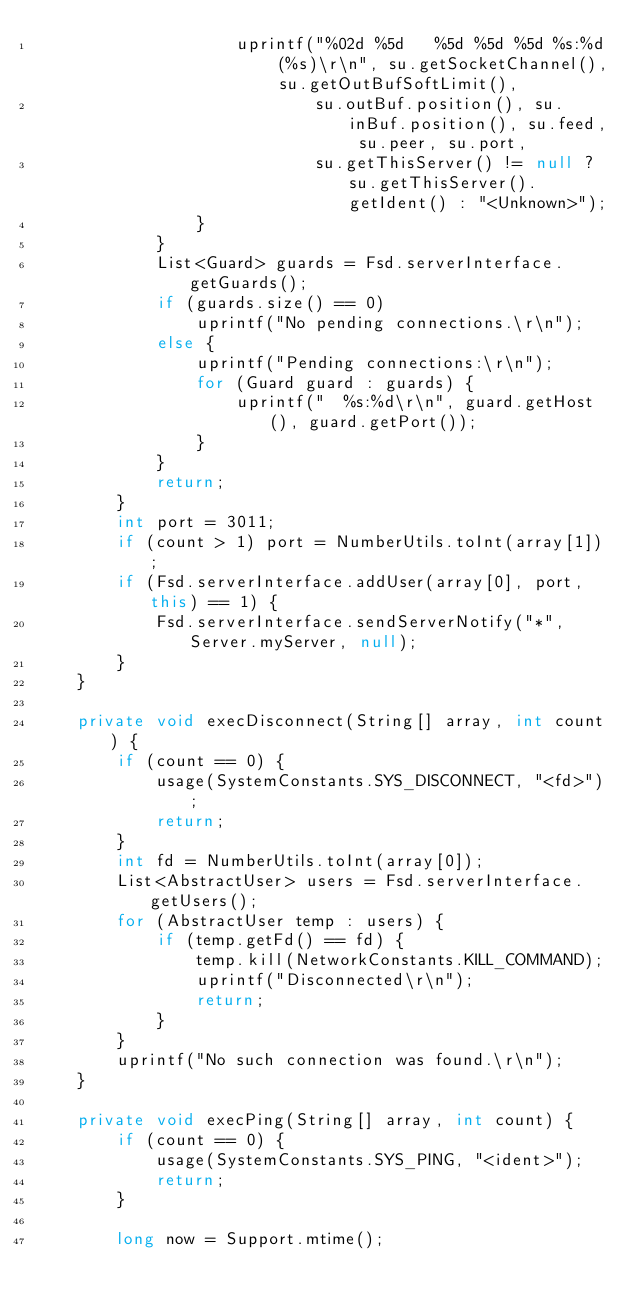Convert code to text. <code><loc_0><loc_0><loc_500><loc_500><_Java_>                    uprintf("%02d %5d   %5d %5d %5d %s:%d (%s)\r\n", su.getSocketChannel(), su.getOutBufSoftLimit(),
                            su.outBuf.position(), su.inBuf.position(), su.feed, su.peer, su.port,
                            su.getThisServer() != null ? su.getThisServer().getIdent() : "<Unknown>");
                }
            }
            List<Guard> guards = Fsd.serverInterface.getGuards();
            if (guards.size() == 0)
                uprintf("No pending connections.\r\n");
            else {
                uprintf("Pending connections:\r\n");
                for (Guard guard : guards) {
                    uprintf("  %s:%d\r\n", guard.getHost(), guard.getPort());
                }
            }
            return;
        }
        int port = 3011;
        if (count > 1) port = NumberUtils.toInt(array[1]);
        if (Fsd.serverInterface.addUser(array[0], port, this) == 1) {
            Fsd.serverInterface.sendServerNotify("*", Server.myServer, null);
        }
    }

    private void execDisconnect(String[] array, int count) {
        if (count == 0) {
            usage(SystemConstants.SYS_DISCONNECT, "<fd>");
            return;
        }
        int fd = NumberUtils.toInt(array[0]);
        List<AbstractUser> users = Fsd.serverInterface.getUsers();
        for (AbstractUser temp : users) {
            if (temp.getFd() == fd) {
                temp.kill(NetworkConstants.KILL_COMMAND);
                uprintf("Disconnected\r\n");
                return;
            }
        }
        uprintf("No such connection was found.\r\n");
    }

    private void execPing(String[] array, int count) {
        if (count == 0) {
            usage(SystemConstants.SYS_PING, "<ident>");
            return;
        }

        long now = Support.mtime();</code> 